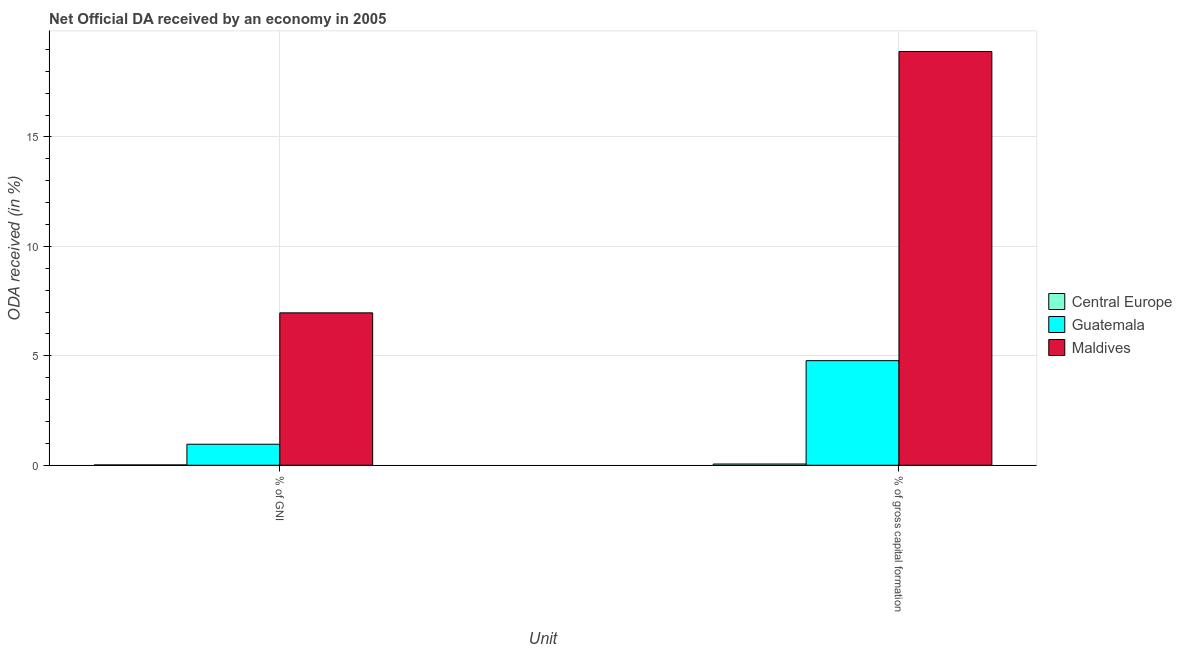Are the number of bars per tick equal to the number of legend labels?
Your answer should be very brief. Yes. How many bars are there on the 2nd tick from the right?
Offer a very short reply. 3. What is the label of the 2nd group of bars from the left?
Provide a short and direct response. % of gross capital formation. What is the oda received as percentage of gross capital formation in Maldives?
Make the answer very short. 18.9. Across all countries, what is the maximum oda received as percentage of gni?
Your response must be concise. 6.96. Across all countries, what is the minimum oda received as percentage of gross capital formation?
Offer a terse response. 0.06. In which country was the oda received as percentage of gross capital formation maximum?
Keep it short and to the point. Maldives. In which country was the oda received as percentage of gni minimum?
Provide a short and direct response. Central Europe. What is the total oda received as percentage of gross capital formation in the graph?
Your response must be concise. 23.74. What is the difference between the oda received as percentage of gni in Central Europe and that in Maldives?
Offer a very short reply. -6.95. What is the difference between the oda received as percentage of gni in Maldives and the oda received as percentage of gross capital formation in Central Europe?
Your response must be concise. 6.91. What is the average oda received as percentage of gross capital formation per country?
Provide a short and direct response. 7.91. What is the difference between the oda received as percentage of gni and oda received as percentage of gross capital formation in Maldives?
Offer a terse response. -11.94. What is the ratio of the oda received as percentage of gross capital formation in Guatemala to that in Maldives?
Give a very brief answer. 0.25. In how many countries, is the oda received as percentage of gni greater than the average oda received as percentage of gni taken over all countries?
Offer a terse response. 1. What does the 2nd bar from the left in % of GNI represents?
Make the answer very short. Guatemala. What does the 2nd bar from the right in % of GNI represents?
Offer a terse response. Guatemala. How many bars are there?
Ensure brevity in your answer.  6. How many countries are there in the graph?
Ensure brevity in your answer.  3. Does the graph contain any zero values?
Your answer should be compact. No. Does the graph contain grids?
Offer a terse response. Yes. Where does the legend appear in the graph?
Your response must be concise. Center right. What is the title of the graph?
Your answer should be compact. Net Official DA received by an economy in 2005. Does "Sint Maarten (Dutch part)" appear as one of the legend labels in the graph?
Give a very brief answer. No. What is the label or title of the X-axis?
Your answer should be compact. Unit. What is the label or title of the Y-axis?
Offer a very short reply. ODA received (in %). What is the ODA received (in %) in Central Europe in % of GNI?
Make the answer very short. 0.01. What is the ODA received (in %) in Guatemala in % of GNI?
Keep it short and to the point. 0.96. What is the ODA received (in %) in Maldives in % of GNI?
Offer a very short reply. 6.96. What is the ODA received (in %) in Central Europe in % of gross capital formation?
Give a very brief answer. 0.06. What is the ODA received (in %) of Guatemala in % of gross capital formation?
Your answer should be compact. 4.78. What is the ODA received (in %) in Maldives in % of gross capital formation?
Ensure brevity in your answer.  18.9. Across all Unit, what is the maximum ODA received (in %) of Central Europe?
Your response must be concise. 0.06. Across all Unit, what is the maximum ODA received (in %) of Guatemala?
Make the answer very short. 4.78. Across all Unit, what is the maximum ODA received (in %) in Maldives?
Offer a very short reply. 18.9. Across all Unit, what is the minimum ODA received (in %) in Central Europe?
Your response must be concise. 0.01. Across all Unit, what is the minimum ODA received (in %) in Guatemala?
Make the answer very short. 0.96. Across all Unit, what is the minimum ODA received (in %) of Maldives?
Provide a succinct answer. 6.96. What is the total ODA received (in %) in Central Europe in the graph?
Provide a short and direct response. 0.07. What is the total ODA received (in %) of Guatemala in the graph?
Your answer should be very brief. 5.74. What is the total ODA received (in %) of Maldives in the graph?
Your answer should be very brief. 25.87. What is the difference between the ODA received (in %) in Central Europe in % of GNI and that in % of gross capital formation?
Your response must be concise. -0.04. What is the difference between the ODA received (in %) of Guatemala in % of GNI and that in % of gross capital formation?
Offer a terse response. -3.82. What is the difference between the ODA received (in %) in Maldives in % of GNI and that in % of gross capital formation?
Keep it short and to the point. -11.94. What is the difference between the ODA received (in %) in Central Europe in % of GNI and the ODA received (in %) in Guatemala in % of gross capital formation?
Provide a succinct answer. -4.76. What is the difference between the ODA received (in %) in Central Europe in % of GNI and the ODA received (in %) in Maldives in % of gross capital formation?
Offer a very short reply. -18.89. What is the difference between the ODA received (in %) in Guatemala in % of GNI and the ODA received (in %) in Maldives in % of gross capital formation?
Give a very brief answer. -17.94. What is the average ODA received (in %) in Central Europe per Unit?
Your answer should be very brief. 0.04. What is the average ODA received (in %) of Guatemala per Unit?
Offer a terse response. 2.87. What is the average ODA received (in %) in Maldives per Unit?
Provide a short and direct response. 12.93. What is the difference between the ODA received (in %) of Central Europe and ODA received (in %) of Guatemala in % of GNI?
Offer a terse response. -0.95. What is the difference between the ODA received (in %) in Central Europe and ODA received (in %) in Maldives in % of GNI?
Give a very brief answer. -6.95. What is the difference between the ODA received (in %) in Guatemala and ODA received (in %) in Maldives in % of GNI?
Offer a very short reply. -6. What is the difference between the ODA received (in %) in Central Europe and ODA received (in %) in Guatemala in % of gross capital formation?
Provide a short and direct response. -4.72. What is the difference between the ODA received (in %) of Central Europe and ODA received (in %) of Maldives in % of gross capital formation?
Ensure brevity in your answer.  -18.85. What is the difference between the ODA received (in %) in Guatemala and ODA received (in %) in Maldives in % of gross capital formation?
Your answer should be compact. -14.13. What is the ratio of the ODA received (in %) in Central Europe in % of GNI to that in % of gross capital formation?
Provide a succinct answer. 0.25. What is the ratio of the ODA received (in %) of Guatemala in % of GNI to that in % of gross capital formation?
Provide a short and direct response. 0.2. What is the ratio of the ODA received (in %) of Maldives in % of GNI to that in % of gross capital formation?
Make the answer very short. 0.37. What is the difference between the highest and the second highest ODA received (in %) of Central Europe?
Your answer should be very brief. 0.04. What is the difference between the highest and the second highest ODA received (in %) in Guatemala?
Provide a succinct answer. 3.82. What is the difference between the highest and the second highest ODA received (in %) of Maldives?
Keep it short and to the point. 11.94. What is the difference between the highest and the lowest ODA received (in %) of Central Europe?
Keep it short and to the point. 0.04. What is the difference between the highest and the lowest ODA received (in %) in Guatemala?
Ensure brevity in your answer.  3.82. What is the difference between the highest and the lowest ODA received (in %) of Maldives?
Your answer should be compact. 11.94. 